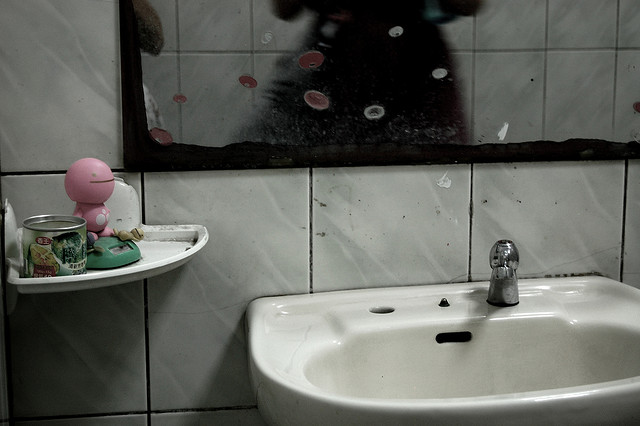<image>Why is there no left faucet? I don't know why there is no left faucet. It could be broken or removed. Why is there no left faucet? There is no left faucet because it is either missing or it was broken or removed. 